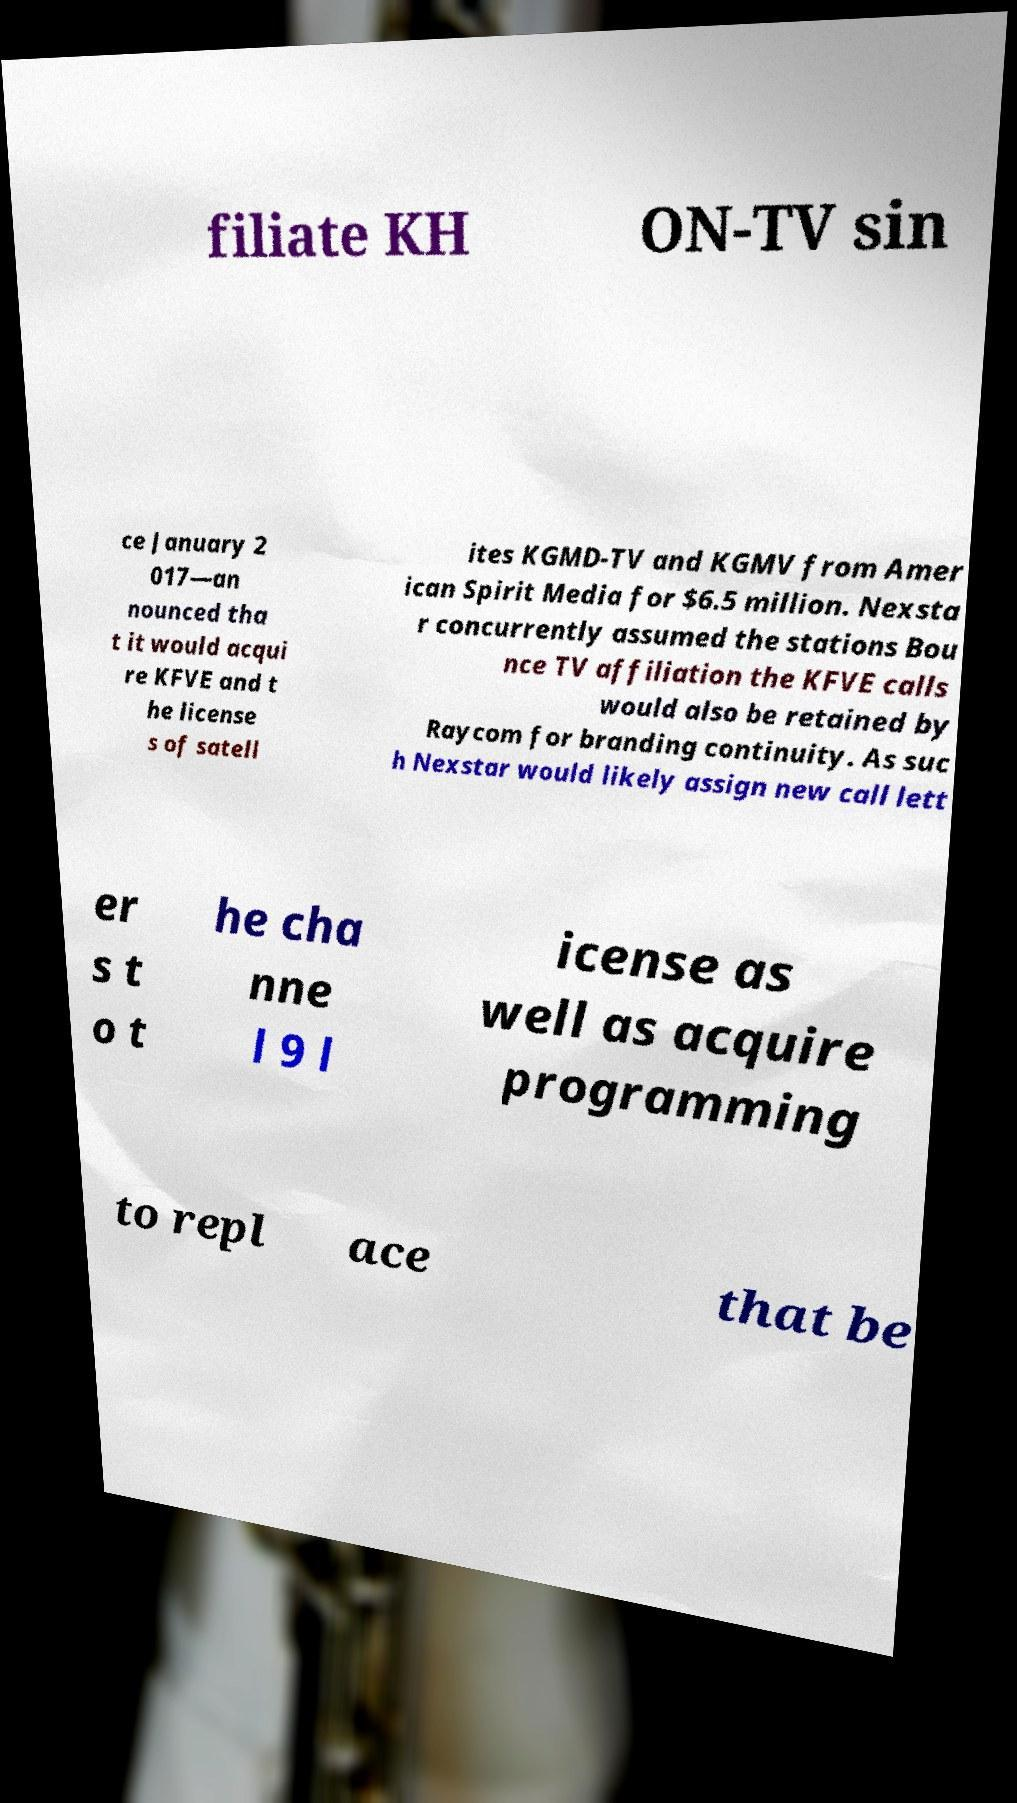I need the written content from this picture converted into text. Can you do that? filiate KH ON-TV sin ce January 2 017—an nounced tha t it would acqui re KFVE and t he license s of satell ites KGMD-TV and KGMV from Amer ican Spirit Media for $6.5 million. Nexsta r concurrently assumed the stations Bou nce TV affiliation the KFVE calls would also be retained by Raycom for branding continuity. As suc h Nexstar would likely assign new call lett er s t o t he cha nne l 9 l icense as well as acquire programming to repl ace that be 